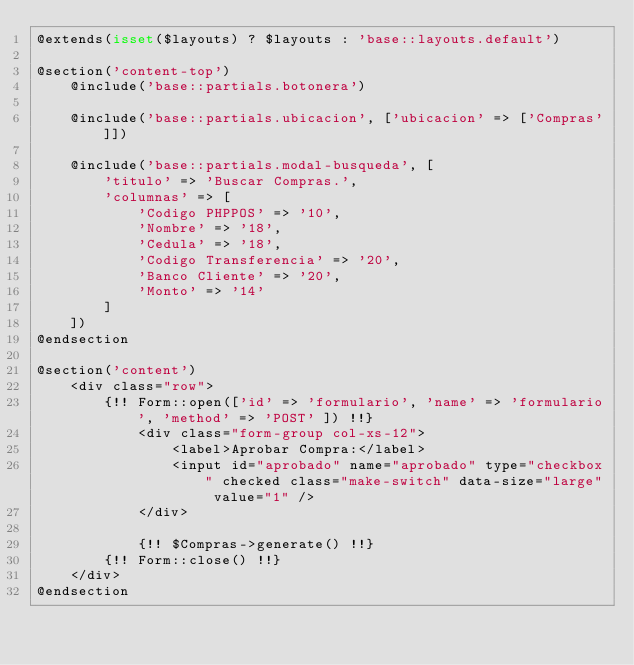<code> <loc_0><loc_0><loc_500><loc_500><_PHP_>@extends(isset($layouts) ? $layouts : 'base::layouts.default')

@section('content-top')
    @include('base::partials.botonera')
    
    @include('base::partials.ubicacion', ['ubicacion' => ['Compras']])

    @include('base::partials.modal-busqueda', [
        'titulo' => 'Buscar Compras.',
        'columnas' => [
            'Codigo PHPPOS' => '10',
			'Nombre' => '18',
			'Cedula' => '18',
			'Codigo Transferencia' => '20',
			'Banco Cliente' => '20',
			'Monto' => '14'
        ]
    ])
@endsection

@section('content')
    <div class="row">
        {!! Form::open(['id' => 'formulario', 'name' => 'formulario', 'method' => 'POST' ]) !!}
        	<div class="form-group col-xs-12">
	        	<label>Aprobar Compra:</label>
	        	<input id="aprobado" name="aprobado" type="checkbox" checked class="make-switch" data-size="large" value="1" />
        	</div>

            {!! $Compras->generate() !!}
        {!! Form::close() !!}
    </div>
@endsection</code> 